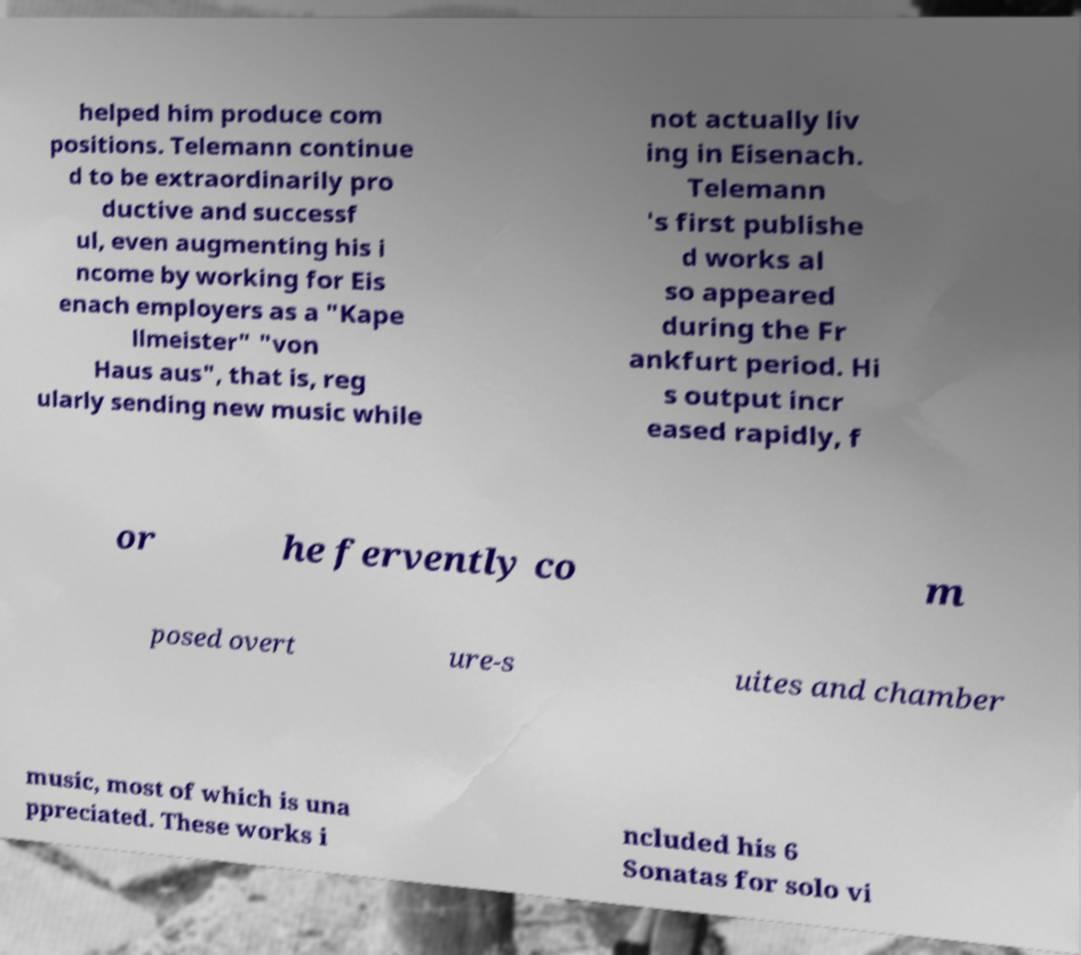Please identify and transcribe the text found in this image. helped him produce com positions. Telemann continue d to be extraordinarily pro ductive and successf ul, even augmenting his i ncome by working for Eis enach employers as a "Kape llmeister" "von Haus aus", that is, reg ularly sending new music while not actually liv ing in Eisenach. Telemann 's first publishe d works al so appeared during the Fr ankfurt period. Hi s output incr eased rapidly, f or he fervently co m posed overt ure-s uites and chamber music, most of which is una ppreciated. These works i ncluded his 6 Sonatas for solo vi 